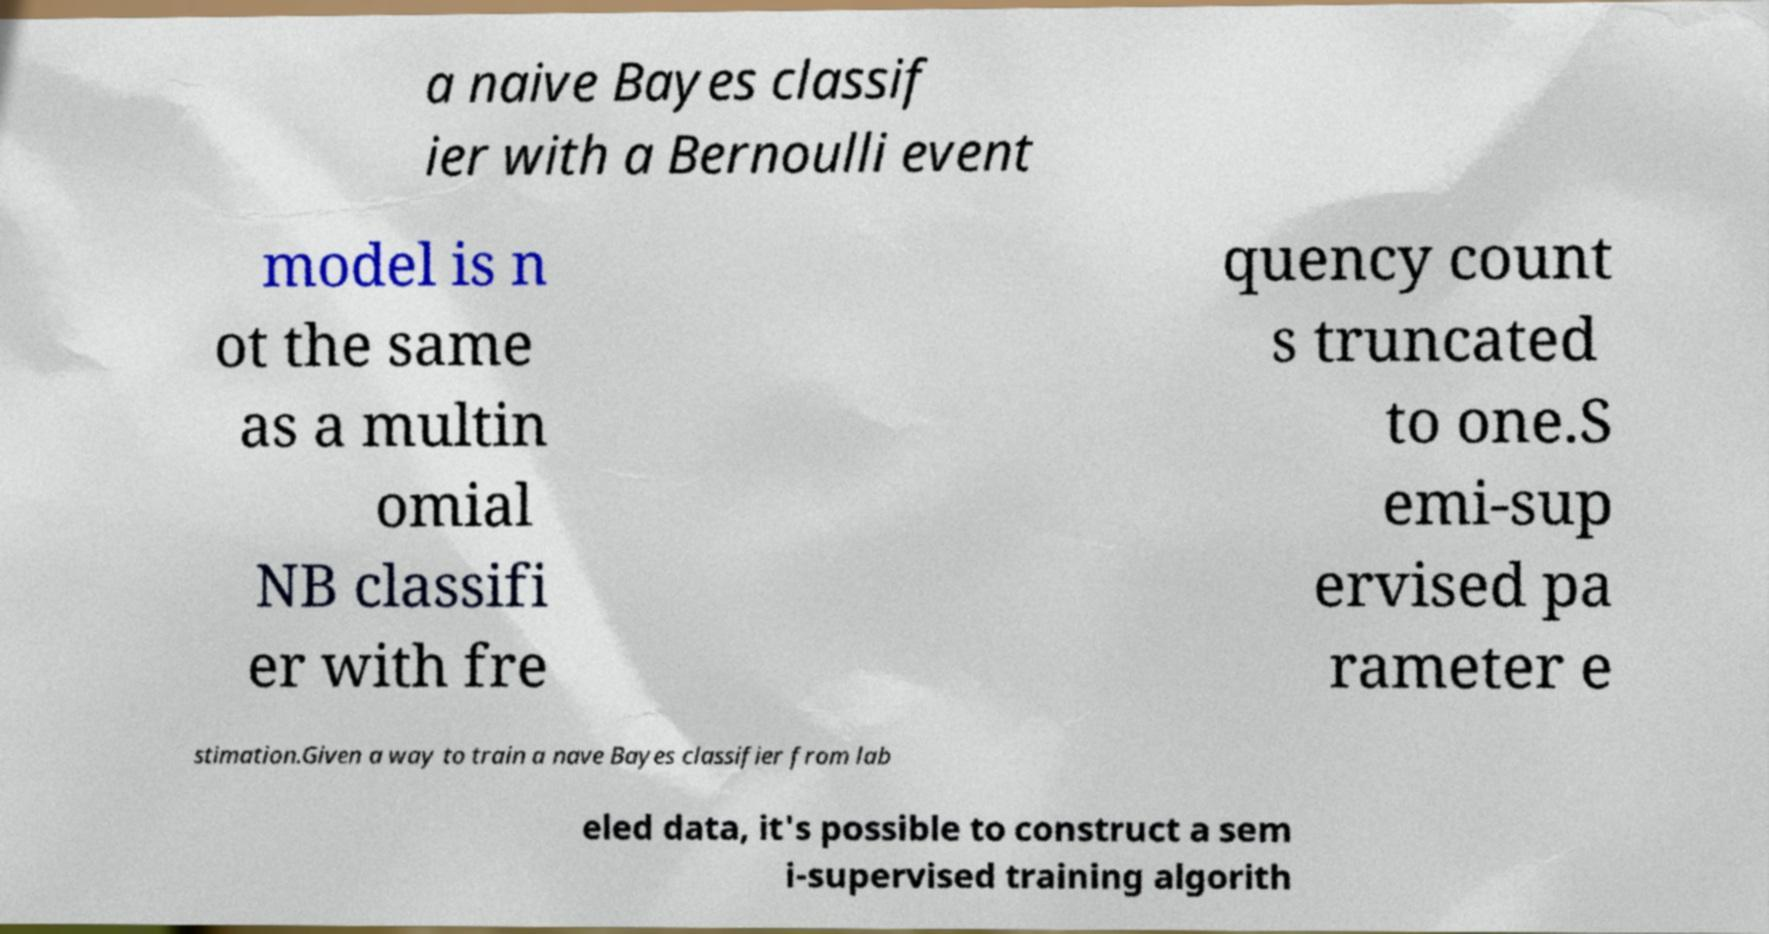For documentation purposes, I need the text within this image transcribed. Could you provide that? a naive Bayes classif ier with a Bernoulli event model is n ot the same as a multin omial NB classifi er with fre quency count s truncated to one.S emi-sup ervised pa rameter e stimation.Given a way to train a nave Bayes classifier from lab eled data, it's possible to construct a sem i-supervised training algorith 